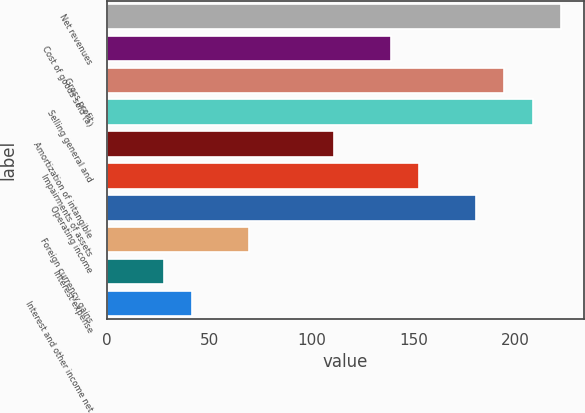Convert chart to OTSL. <chart><loc_0><loc_0><loc_500><loc_500><bar_chart><fcel>Net revenues<fcel>Cost of goods sold (a)<fcel>Gross profit<fcel>Selling general and<fcel>Amortization of intangible<fcel>Impairments of assets<fcel>Operating income<fcel>Foreign currency gains<fcel>Interest expense<fcel>Interest and other income net<nl><fcel>222.09<fcel>138.81<fcel>194.33<fcel>208.21<fcel>111.05<fcel>152.69<fcel>180.45<fcel>69.41<fcel>27.77<fcel>41.65<nl></chart> 